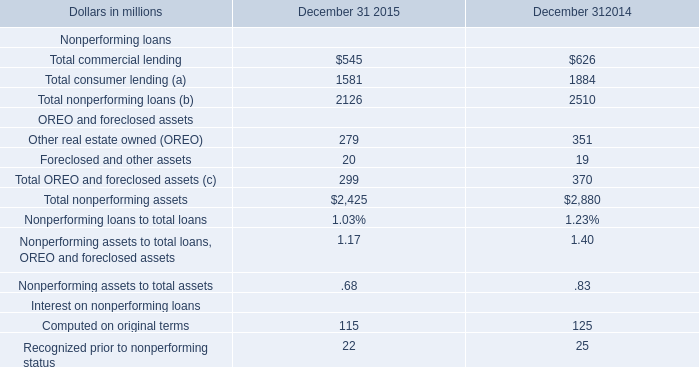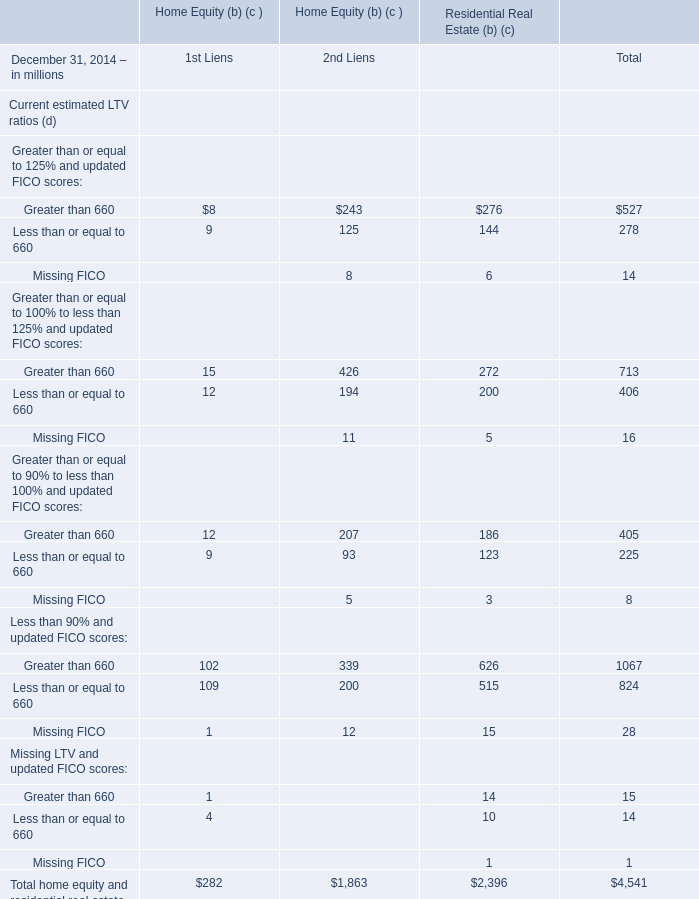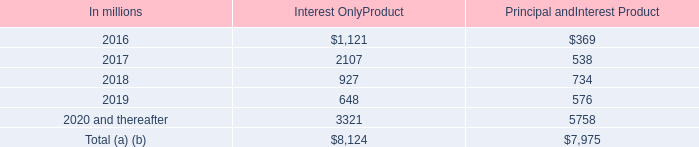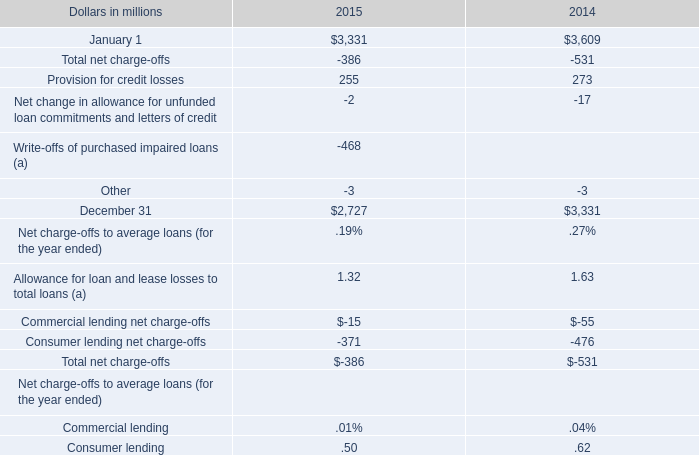What's the average of the Provision for credit losses in the years where Foreclosed and other assets for OREO and foreclosed assets is positive? 
Computations: ((255 + 273) / 2)
Answer: 264.0. 